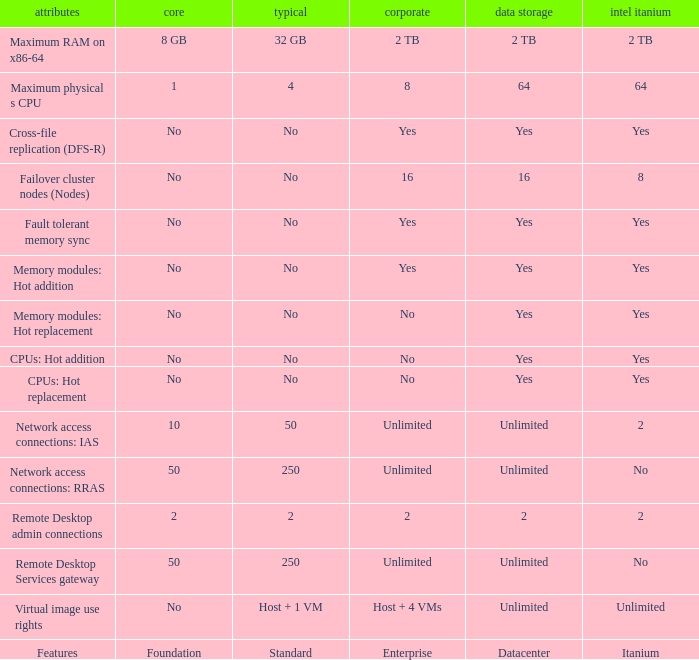Can you give me this table as a dict? {'header': ['attributes', 'core', 'typical', 'corporate', 'data storage', 'intel itanium'], 'rows': [['Maximum RAM on x86-64', '8 GB', '32 GB', '2 TB', '2 TB', '2 TB'], ['Maximum physical s CPU', '1', '4', '8', '64', '64'], ['Cross-file replication (DFS-R)', 'No', 'No', 'Yes', 'Yes', 'Yes'], ['Failover cluster nodes (Nodes)', 'No', 'No', '16', '16', '8'], ['Fault tolerant memory sync', 'No', 'No', 'Yes', 'Yes', 'Yes'], ['Memory modules: Hot addition', 'No', 'No', 'Yes', 'Yes', 'Yes'], ['Memory modules: Hot replacement', 'No', 'No', 'No', 'Yes', 'Yes'], ['CPUs: Hot addition', 'No', 'No', 'No', 'Yes', 'Yes'], ['CPUs: Hot replacement', 'No', 'No', 'No', 'Yes', 'Yes'], ['Network access connections: IAS', '10', '50', 'Unlimited', 'Unlimited', '2'], ['Network access connections: RRAS', '50', '250', 'Unlimited', 'Unlimited', 'No'], ['Remote Desktop admin connections', '2', '2', '2', '2', '2'], ['Remote Desktop Services gateway', '50', '250', 'Unlimited', 'Unlimited', 'No'], ['Virtual image use rights', 'No', 'Host + 1 VM', 'Host + 4 VMs', 'Unlimited', 'Unlimited'], ['Features', 'Foundation', 'Standard', 'Enterprise', 'Datacenter', 'Itanium']]} What Datacenter is listed against the network access connections: rras Feature? Unlimited. 